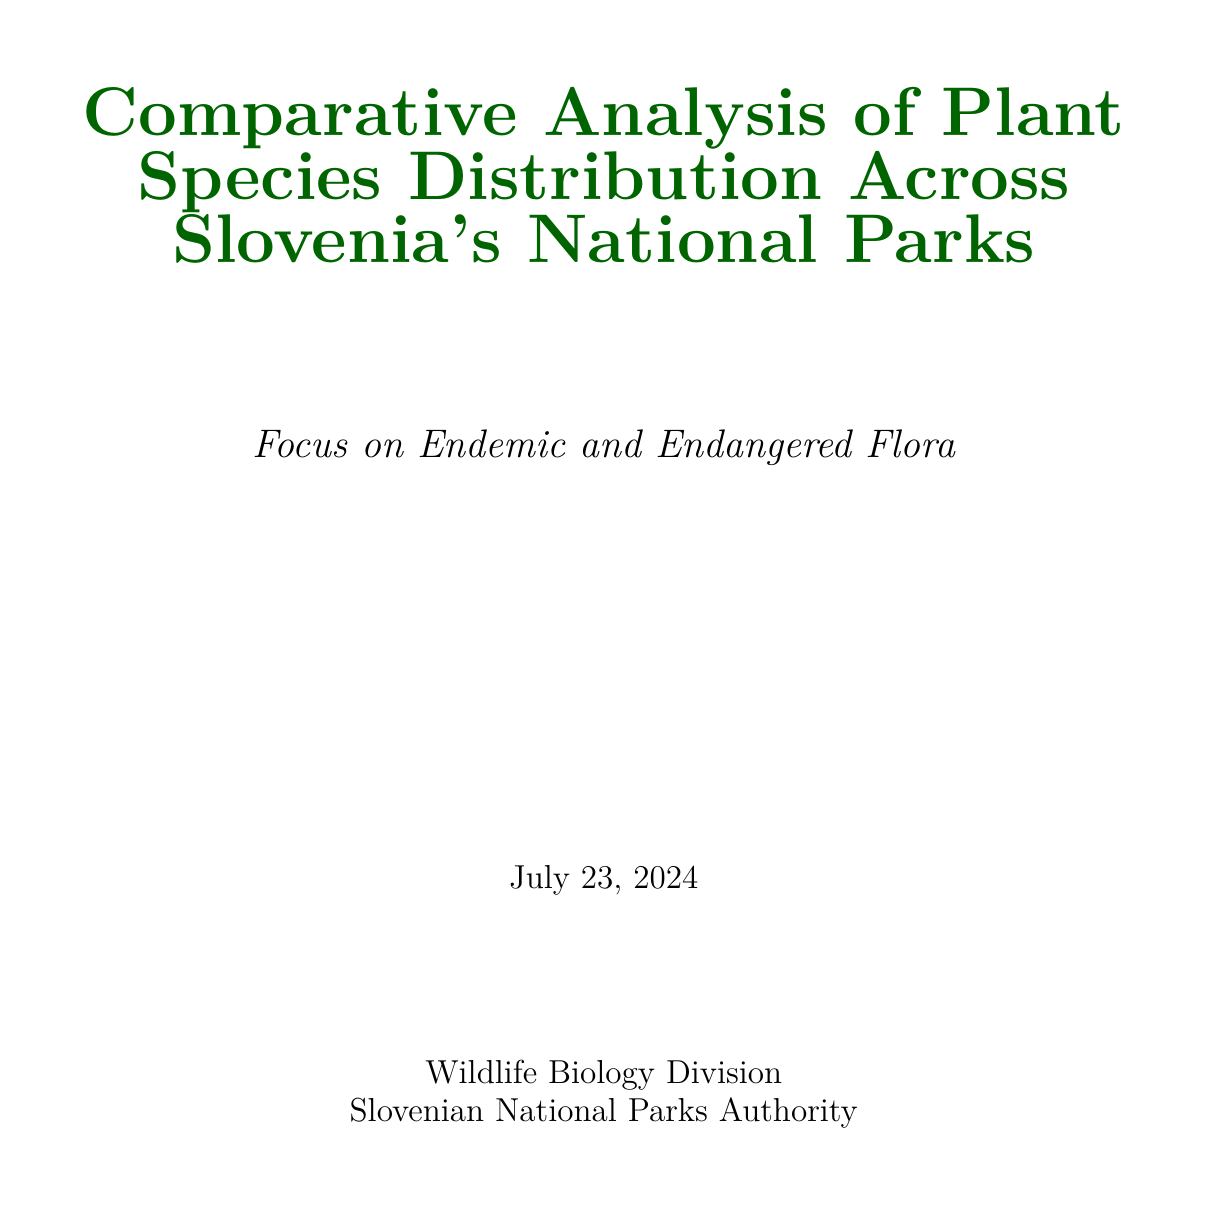What is the title of the report? The title of the report is the first line that summarizes the study's focus on plant species in Slovenia's national parks.
Answer: Comparative Analysis of Plant Species Distribution Across Slovenia's National Parks: Focus on Endemic and Endangered Flora Which national park is the largest by area? This information can be found in the overview section of national parks, listing their sizes.
Answer: Triglav National Park What is the conservation status of Zois' bellflower? The conservation status is mentioned in the section on endemic species, under Zois' bellflower details.
Answer: Near Threatened How many hectares is Kozjanski Regional Park? The size of the park is detailed in the table listing national parks and their sizes.
Answer: 19,600 hectares Which park is known for its unique subterranean flora? This information is identified under the comparative analysis of species richness.
Answer: Škocjan Caves Regional Park What is a major threat to the Edelweiss plant? The threats are mentioned in the endangered species section under Edelweiss.
Answer: Climate change What type of conservation effort includes monitoring programs? This type of effort is listed under in-situ conservation efforts in the report.
Answer: In-situ Conservation How many national parks are discussed in the report? The introduction of the document outlines the number of national parks being analyzed.
Answer: Three 